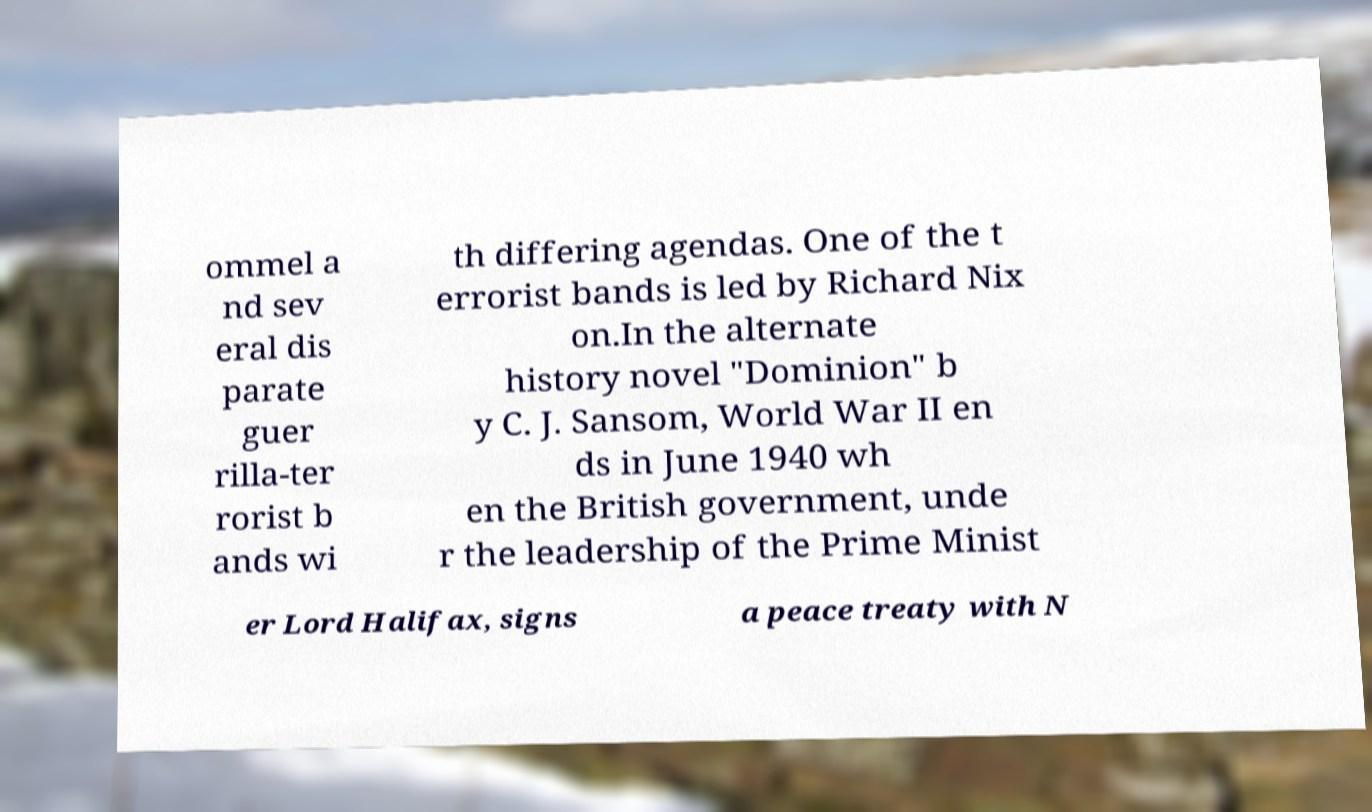Can you read and provide the text displayed in the image?This photo seems to have some interesting text. Can you extract and type it out for me? ommel a nd sev eral dis parate guer rilla-ter rorist b ands wi th differing agendas. One of the t errorist bands is led by Richard Nix on.In the alternate history novel "Dominion" b y C. J. Sansom, World War II en ds in June 1940 wh en the British government, unde r the leadership of the Prime Minist er Lord Halifax, signs a peace treaty with N 